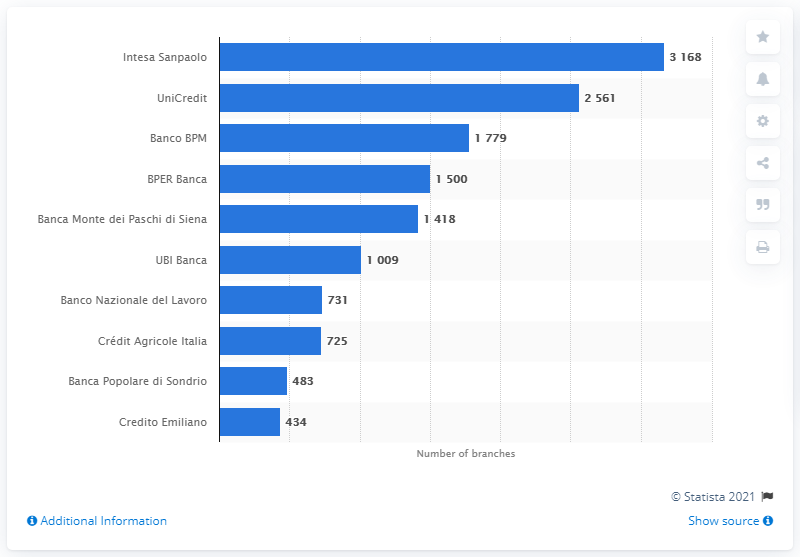Draw attention to some important aspects in this diagram. As of March 2021, UniCredit had 2,561 bank branches. 